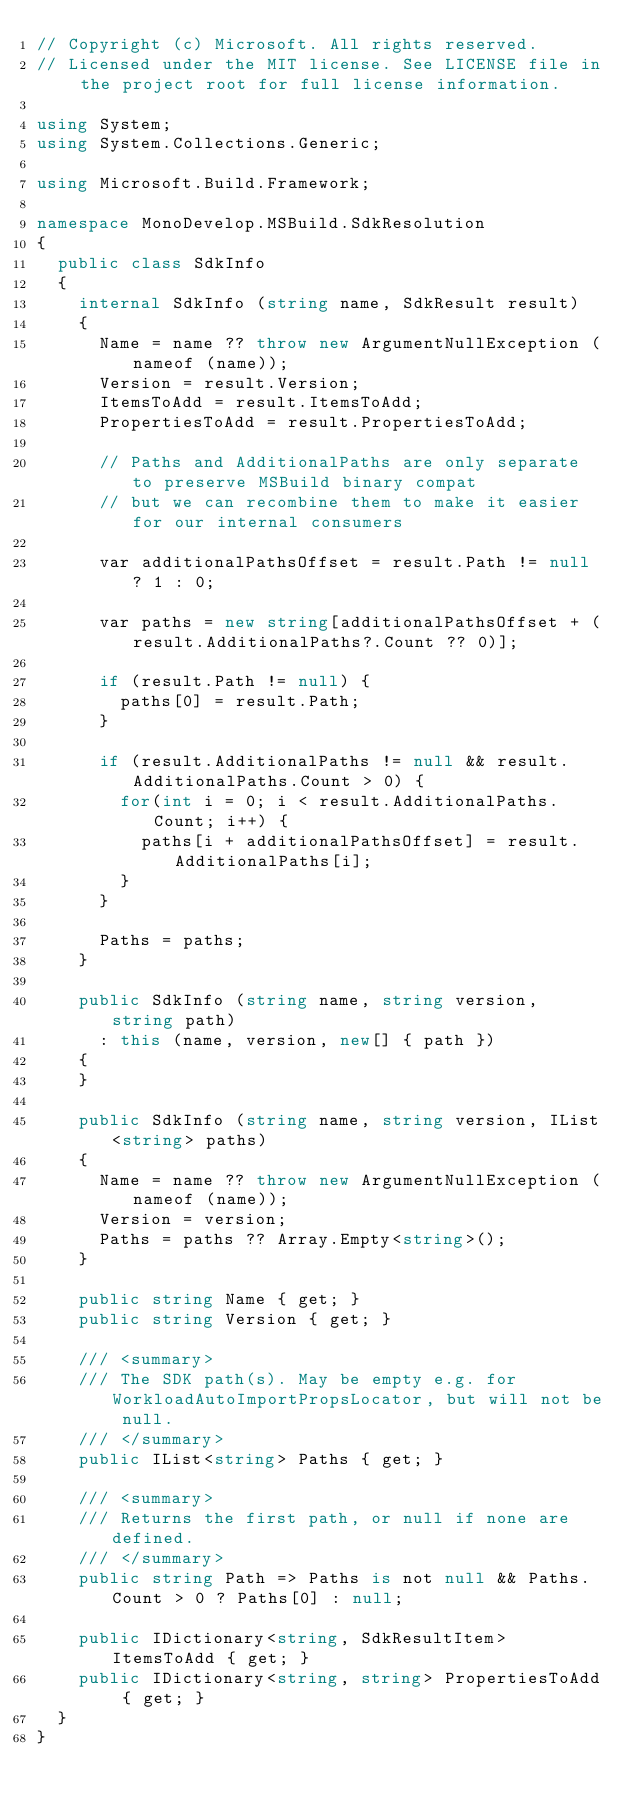<code> <loc_0><loc_0><loc_500><loc_500><_C#_>// Copyright (c) Microsoft. All rights reserved.
// Licensed under the MIT license. See LICENSE file in the project root for full license information.

using System;
using System.Collections.Generic;

using Microsoft.Build.Framework;

namespace MonoDevelop.MSBuild.SdkResolution
{
	public class SdkInfo
	{
		internal SdkInfo (string name, SdkResult result)
		{
			Name = name ?? throw new ArgumentNullException (nameof (name));
			Version = result.Version;
			ItemsToAdd = result.ItemsToAdd;
			PropertiesToAdd = result.PropertiesToAdd;

			// Paths and AdditionalPaths are only separate to preserve MSBuild binary compat
			// but we can recombine them to make it easier for our internal consumers

			var additionalPathsOffset = result.Path != null ? 1 : 0;

			var paths = new string[additionalPathsOffset + (result.AdditionalPaths?.Count ?? 0)];

			if (result.Path != null) {
				paths[0] = result.Path;
			}

			if (result.AdditionalPaths != null && result.AdditionalPaths.Count > 0) {
				for(int i = 0; i < result.AdditionalPaths.Count; i++) {
					paths[i + additionalPathsOffset] = result.AdditionalPaths[i];
				}
			}

			Paths = paths;
		}

		public SdkInfo (string name, string version, string path)
			: this (name, version, new[] { path })
		{
		}

		public SdkInfo (string name, string version, IList<string> paths)
		{
			Name = name ?? throw new ArgumentNullException (nameof (name));
			Version = version;
			Paths = paths ?? Array.Empty<string>();
		}

		public string Name { get; }
		public string Version { get; }

		/// <summary>
		/// The SDK path(s). May be empty e.g. for WorkloadAutoImportPropsLocator, but will not be null.
		/// </summary>
		public IList<string> Paths { get; }

		/// <summary>
		/// Returns the first path, or null if none are defined.
		/// </summary>
		public string Path => Paths is not null && Paths.Count > 0 ? Paths[0] : null;

		public IDictionary<string, SdkResultItem> ItemsToAdd { get; }
		public IDictionary<string, string> PropertiesToAdd { get; }
	}
}
</code> 